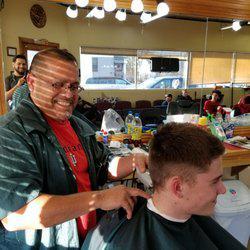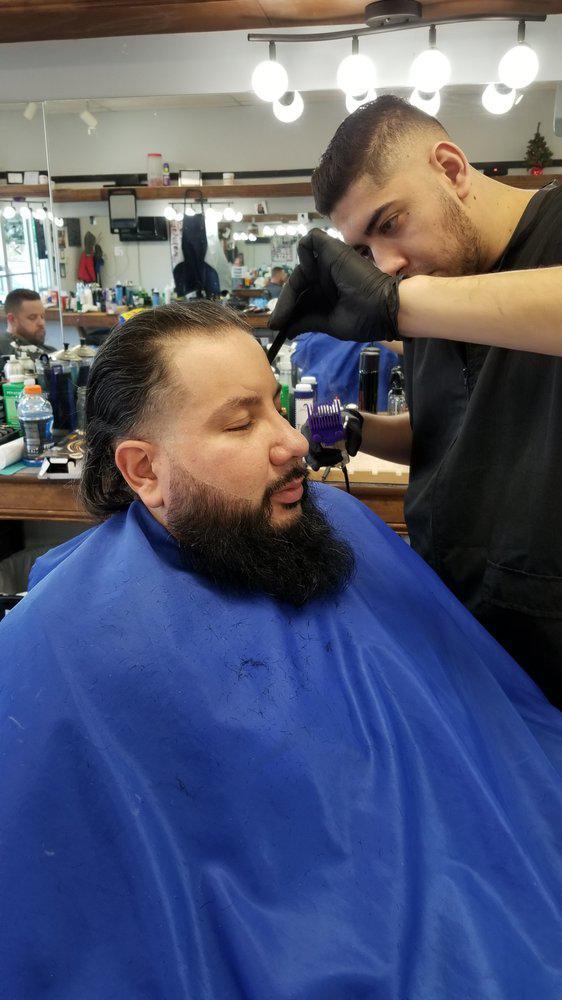The first image is the image on the left, the second image is the image on the right. Assess this claim about the two images: "The left and right image contains the same number of barbers shaving and combing men with dark hair.". Correct or not? Answer yes or no. Yes. The first image is the image on the left, the second image is the image on the right. Analyze the images presented: Is the assertion "Each image shows a barber in the foreground working on the hair of a customer wearing a smock, and only one of the images shows a customer in a blue smock." valid? Answer yes or no. Yes. 